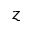<formula> <loc_0><loc_0><loc_500><loc_500>z</formula> 